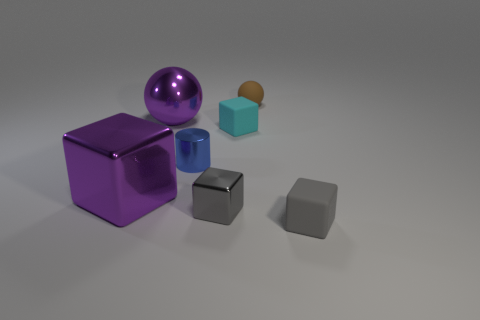Are there any metal things that have the same color as the big shiny sphere?
Offer a very short reply. Yes. Is the color of the large metal ball the same as the big shiny cube?
Offer a terse response. Yes. Is the material of the brown ball the same as the blue thing?
Ensure brevity in your answer.  No. The object that is the same color as the small metallic cube is what size?
Keep it short and to the point. Small. Are there fewer rubber things that are on the right side of the small cylinder than small cylinders that are behind the tiny cyan block?
Your response must be concise. No. Is there anything else that has the same size as the blue shiny object?
Offer a terse response. Yes. The small brown object has what shape?
Your response must be concise. Sphere. What is the sphere that is on the right side of the tiny cylinder made of?
Make the answer very short. Rubber. What size is the gray block behind the tiny thing that is in front of the gray thing to the left of the small cyan object?
Ensure brevity in your answer.  Small. Is the material of the large purple thing that is behind the cyan rubber cube the same as the gray cube to the right of the cyan thing?
Provide a short and direct response. No. 